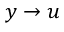<formula> <loc_0><loc_0><loc_500><loc_500>y \to u</formula> 